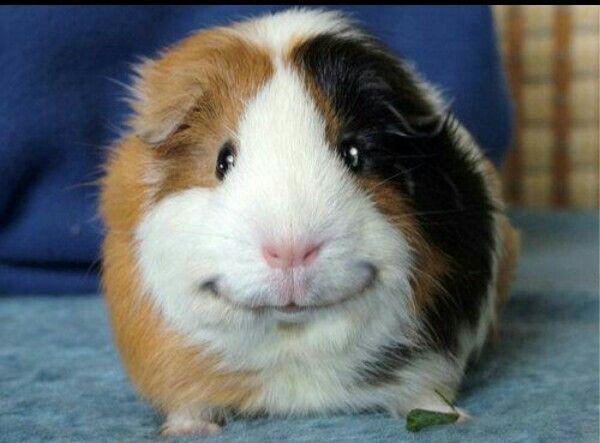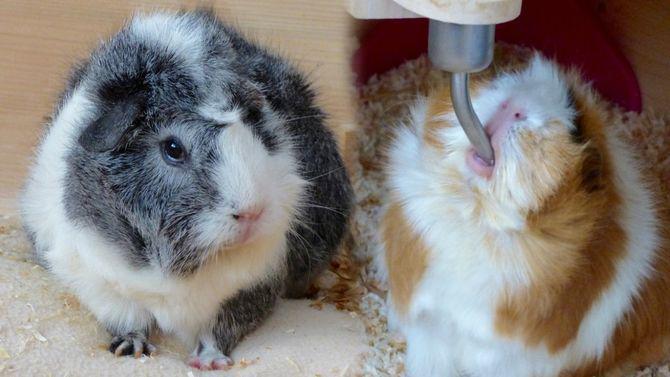The first image is the image on the left, the second image is the image on the right. Evaluate the accuracy of this statement regarding the images: "There are three hamsters in total.". Is it true? Answer yes or no. Yes. The first image is the image on the left, the second image is the image on the right. Examine the images to the left and right. Is the description "In total, three guinea pigs are shown, and the right image contains more animals than the left image." accurate? Answer yes or no. Yes. 